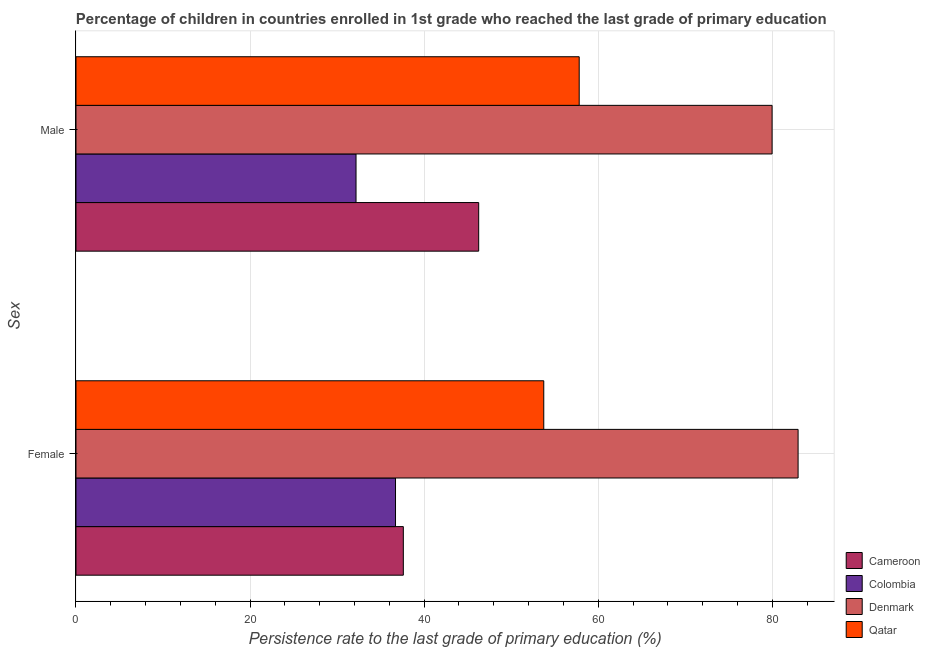How many bars are there on the 1st tick from the bottom?
Your answer should be very brief. 4. What is the persistence rate of male students in Denmark?
Your response must be concise. 79.97. Across all countries, what is the maximum persistence rate of male students?
Ensure brevity in your answer.  79.97. Across all countries, what is the minimum persistence rate of female students?
Your answer should be compact. 36.71. In which country was the persistence rate of male students minimum?
Provide a short and direct response. Colombia. What is the total persistence rate of female students in the graph?
Ensure brevity in your answer.  211.01. What is the difference between the persistence rate of male students in Colombia and that in Denmark?
Provide a short and direct response. -47.8. What is the difference between the persistence rate of male students in Denmark and the persistence rate of female students in Colombia?
Provide a short and direct response. 43.26. What is the average persistence rate of male students per country?
Keep it short and to the point. 54.05. What is the difference between the persistence rate of male students and persistence rate of female students in Colombia?
Ensure brevity in your answer.  -4.54. In how many countries, is the persistence rate of male students greater than 28 %?
Your answer should be very brief. 4. What is the ratio of the persistence rate of male students in Cameroon to that in Qatar?
Offer a terse response. 0.8. Is the persistence rate of male students in Cameroon less than that in Colombia?
Offer a terse response. No. What does the 4th bar from the top in Female represents?
Offer a terse response. Cameroon. What does the 1st bar from the bottom in Female represents?
Ensure brevity in your answer.  Cameroon. Are all the bars in the graph horizontal?
Make the answer very short. Yes. How many countries are there in the graph?
Offer a very short reply. 4. What is the difference between two consecutive major ticks on the X-axis?
Your answer should be compact. 20. Does the graph contain grids?
Provide a succinct answer. Yes. How are the legend labels stacked?
Your response must be concise. Vertical. What is the title of the graph?
Keep it short and to the point. Percentage of children in countries enrolled in 1st grade who reached the last grade of primary education. Does "Cote d'Ivoire" appear as one of the legend labels in the graph?
Offer a very short reply. No. What is the label or title of the X-axis?
Provide a short and direct response. Persistence rate to the last grade of primary education (%). What is the label or title of the Y-axis?
Offer a very short reply. Sex. What is the Persistence rate to the last grade of primary education (%) of Cameroon in Female?
Ensure brevity in your answer.  37.61. What is the Persistence rate to the last grade of primary education (%) of Colombia in Female?
Offer a very short reply. 36.71. What is the Persistence rate to the last grade of primary education (%) of Denmark in Female?
Your answer should be compact. 82.96. What is the Persistence rate to the last grade of primary education (%) in Qatar in Female?
Make the answer very short. 53.74. What is the Persistence rate to the last grade of primary education (%) in Cameroon in Male?
Make the answer very short. 46.26. What is the Persistence rate to the last grade of primary education (%) of Colombia in Male?
Provide a short and direct response. 32.17. What is the Persistence rate to the last grade of primary education (%) of Denmark in Male?
Your response must be concise. 79.97. What is the Persistence rate to the last grade of primary education (%) in Qatar in Male?
Your answer should be very brief. 57.81. Across all Sex, what is the maximum Persistence rate to the last grade of primary education (%) in Cameroon?
Ensure brevity in your answer.  46.26. Across all Sex, what is the maximum Persistence rate to the last grade of primary education (%) of Colombia?
Offer a terse response. 36.71. Across all Sex, what is the maximum Persistence rate to the last grade of primary education (%) in Denmark?
Make the answer very short. 82.96. Across all Sex, what is the maximum Persistence rate to the last grade of primary education (%) of Qatar?
Your answer should be compact. 57.81. Across all Sex, what is the minimum Persistence rate to the last grade of primary education (%) of Cameroon?
Offer a terse response. 37.61. Across all Sex, what is the minimum Persistence rate to the last grade of primary education (%) of Colombia?
Provide a short and direct response. 32.17. Across all Sex, what is the minimum Persistence rate to the last grade of primary education (%) of Denmark?
Provide a succinct answer. 79.97. Across all Sex, what is the minimum Persistence rate to the last grade of primary education (%) of Qatar?
Keep it short and to the point. 53.74. What is the total Persistence rate to the last grade of primary education (%) of Cameroon in the graph?
Offer a very short reply. 83.87. What is the total Persistence rate to the last grade of primary education (%) in Colombia in the graph?
Provide a succinct answer. 68.88. What is the total Persistence rate to the last grade of primary education (%) of Denmark in the graph?
Give a very brief answer. 162.93. What is the total Persistence rate to the last grade of primary education (%) in Qatar in the graph?
Ensure brevity in your answer.  111.55. What is the difference between the Persistence rate to the last grade of primary education (%) in Cameroon in Female and that in Male?
Give a very brief answer. -8.66. What is the difference between the Persistence rate to the last grade of primary education (%) of Colombia in Female and that in Male?
Ensure brevity in your answer.  4.54. What is the difference between the Persistence rate to the last grade of primary education (%) of Denmark in Female and that in Male?
Offer a terse response. 2.99. What is the difference between the Persistence rate to the last grade of primary education (%) of Qatar in Female and that in Male?
Provide a succinct answer. -4.07. What is the difference between the Persistence rate to the last grade of primary education (%) of Cameroon in Female and the Persistence rate to the last grade of primary education (%) of Colombia in Male?
Ensure brevity in your answer.  5.43. What is the difference between the Persistence rate to the last grade of primary education (%) of Cameroon in Female and the Persistence rate to the last grade of primary education (%) of Denmark in Male?
Offer a terse response. -42.36. What is the difference between the Persistence rate to the last grade of primary education (%) of Cameroon in Female and the Persistence rate to the last grade of primary education (%) of Qatar in Male?
Your response must be concise. -20.21. What is the difference between the Persistence rate to the last grade of primary education (%) of Colombia in Female and the Persistence rate to the last grade of primary education (%) of Denmark in Male?
Your response must be concise. -43.26. What is the difference between the Persistence rate to the last grade of primary education (%) in Colombia in Female and the Persistence rate to the last grade of primary education (%) in Qatar in Male?
Provide a short and direct response. -21.1. What is the difference between the Persistence rate to the last grade of primary education (%) of Denmark in Female and the Persistence rate to the last grade of primary education (%) of Qatar in Male?
Ensure brevity in your answer.  25.15. What is the average Persistence rate to the last grade of primary education (%) in Cameroon per Sex?
Your answer should be very brief. 41.93. What is the average Persistence rate to the last grade of primary education (%) of Colombia per Sex?
Offer a very short reply. 34.44. What is the average Persistence rate to the last grade of primary education (%) of Denmark per Sex?
Offer a very short reply. 81.46. What is the average Persistence rate to the last grade of primary education (%) in Qatar per Sex?
Ensure brevity in your answer.  55.78. What is the difference between the Persistence rate to the last grade of primary education (%) of Cameroon and Persistence rate to the last grade of primary education (%) of Colombia in Female?
Give a very brief answer. 0.9. What is the difference between the Persistence rate to the last grade of primary education (%) of Cameroon and Persistence rate to the last grade of primary education (%) of Denmark in Female?
Your answer should be compact. -45.35. What is the difference between the Persistence rate to the last grade of primary education (%) of Cameroon and Persistence rate to the last grade of primary education (%) of Qatar in Female?
Make the answer very short. -16.13. What is the difference between the Persistence rate to the last grade of primary education (%) in Colombia and Persistence rate to the last grade of primary education (%) in Denmark in Female?
Your response must be concise. -46.25. What is the difference between the Persistence rate to the last grade of primary education (%) in Colombia and Persistence rate to the last grade of primary education (%) in Qatar in Female?
Give a very brief answer. -17.03. What is the difference between the Persistence rate to the last grade of primary education (%) in Denmark and Persistence rate to the last grade of primary education (%) in Qatar in Female?
Provide a succinct answer. 29.22. What is the difference between the Persistence rate to the last grade of primary education (%) of Cameroon and Persistence rate to the last grade of primary education (%) of Colombia in Male?
Make the answer very short. 14.09. What is the difference between the Persistence rate to the last grade of primary education (%) of Cameroon and Persistence rate to the last grade of primary education (%) of Denmark in Male?
Keep it short and to the point. -33.71. What is the difference between the Persistence rate to the last grade of primary education (%) of Cameroon and Persistence rate to the last grade of primary education (%) of Qatar in Male?
Offer a very short reply. -11.55. What is the difference between the Persistence rate to the last grade of primary education (%) in Colombia and Persistence rate to the last grade of primary education (%) in Denmark in Male?
Make the answer very short. -47.8. What is the difference between the Persistence rate to the last grade of primary education (%) of Colombia and Persistence rate to the last grade of primary education (%) of Qatar in Male?
Offer a terse response. -25.64. What is the difference between the Persistence rate to the last grade of primary education (%) in Denmark and Persistence rate to the last grade of primary education (%) in Qatar in Male?
Give a very brief answer. 22.16. What is the ratio of the Persistence rate to the last grade of primary education (%) of Cameroon in Female to that in Male?
Your answer should be very brief. 0.81. What is the ratio of the Persistence rate to the last grade of primary education (%) in Colombia in Female to that in Male?
Offer a very short reply. 1.14. What is the ratio of the Persistence rate to the last grade of primary education (%) in Denmark in Female to that in Male?
Your response must be concise. 1.04. What is the ratio of the Persistence rate to the last grade of primary education (%) of Qatar in Female to that in Male?
Your answer should be very brief. 0.93. What is the difference between the highest and the second highest Persistence rate to the last grade of primary education (%) in Cameroon?
Give a very brief answer. 8.66. What is the difference between the highest and the second highest Persistence rate to the last grade of primary education (%) in Colombia?
Provide a short and direct response. 4.54. What is the difference between the highest and the second highest Persistence rate to the last grade of primary education (%) in Denmark?
Keep it short and to the point. 2.99. What is the difference between the highest and the second highest Persistence rate to the last grade of primary education (%) of Qatar?
Your response must be concise. 4.07. What is the difference between the highest and the lowest Persistence rate to the last grade of primary education (%) in Cameroon?
Keep it short and to the point. 8.66. What is the difference between the highest and the lowest Persistence rate to the last grade of primary education (%) of Colombia?
Your answer should be compact. 4.54. What is the difference between the highest and the lowest Persistence rate to the last grade of primary education (%) of Denmark?
Provide a short and direct response. 2.99. What is the difference between the highest and the lowest Persistence rate to the last grade of primary education (%) of Qatar?
Your response must be concise. 4.07. 